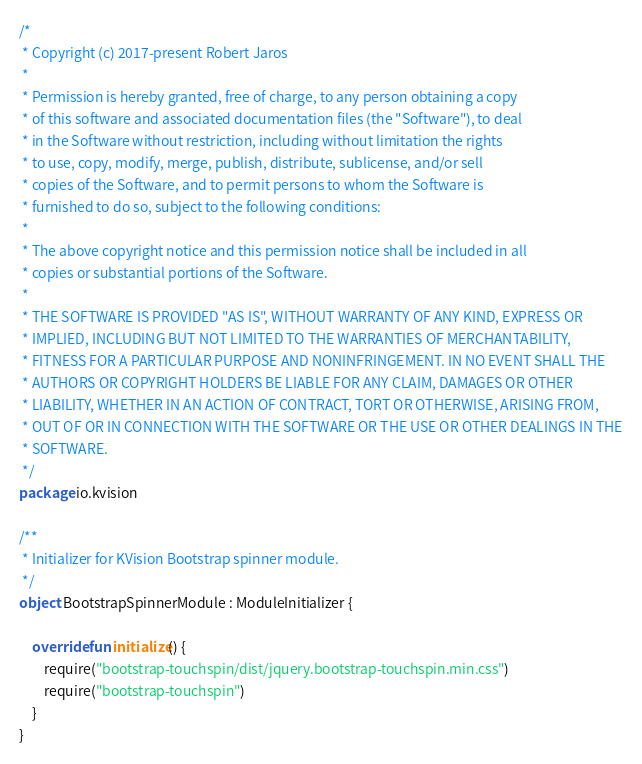Convert code to text. <code><loc_0><loc_0><loc_500><loc_500><_Kotlin_>/*
 * Copyright (c) 2017-present Robert Jaros
 *
 * Permission is hereby granted, free of charge, to any person obtaining a copy
 * of this software and associated documentation files (the "Software"), to deal
 * in the Software without restriction, including without limitation the rights
 * to use, copy, modify, merge, publish, distribute, sublicense, and/or sell
 * copies of the Software, and to permit persons to whom the Software is
 * furnished to do so, subject to the following conditions:
 *
 * The above copyright notice and this permission notice shall be included in all
 * copies or substantial portions of the Software.
 *
 * THE SOFTWARE IS PROVIDED "AS IS", WITHOUT WARRANTY OF ANY KIND, EXPRESS OR
 * IMPLIED, INCLUDING BUT NOT LIMITED TO THE WARRANTIES OF MERCHANTABILITY,
 * FITNESS FOR A PARTICULAR PURPOSE AND NONINFRINGEMENT. IN NO EVENT SHALL THE
 * AUTHORS OR COPYRIGHT HOLDERS BE LIABLE FOR ANY CLAIM, DAMAGES OR OTHER
 * LIABILITY, WHETHER IN AN ACTION OF CONTRACT, TORT OR OTHERWISE, ARISING FROM,
 * OUT OF OR IN CONNECTION WITH THE SOFTWARE OR THE USE OR OTHER DEALINGS IN THE
 * SOFTWARE.
 */
package io.kvision

/**
 * Initializer for KVision Bootstrap spinner module.
 */
object BootstrapSpinnerModule : ModuleInitializer {

    override fun initialize() {
        require("bootstrap-touchspin/dist/jquery.bootstrap-touchspin.min.css")
        require("bootstrap-touchspin")
    }
}
</code> 